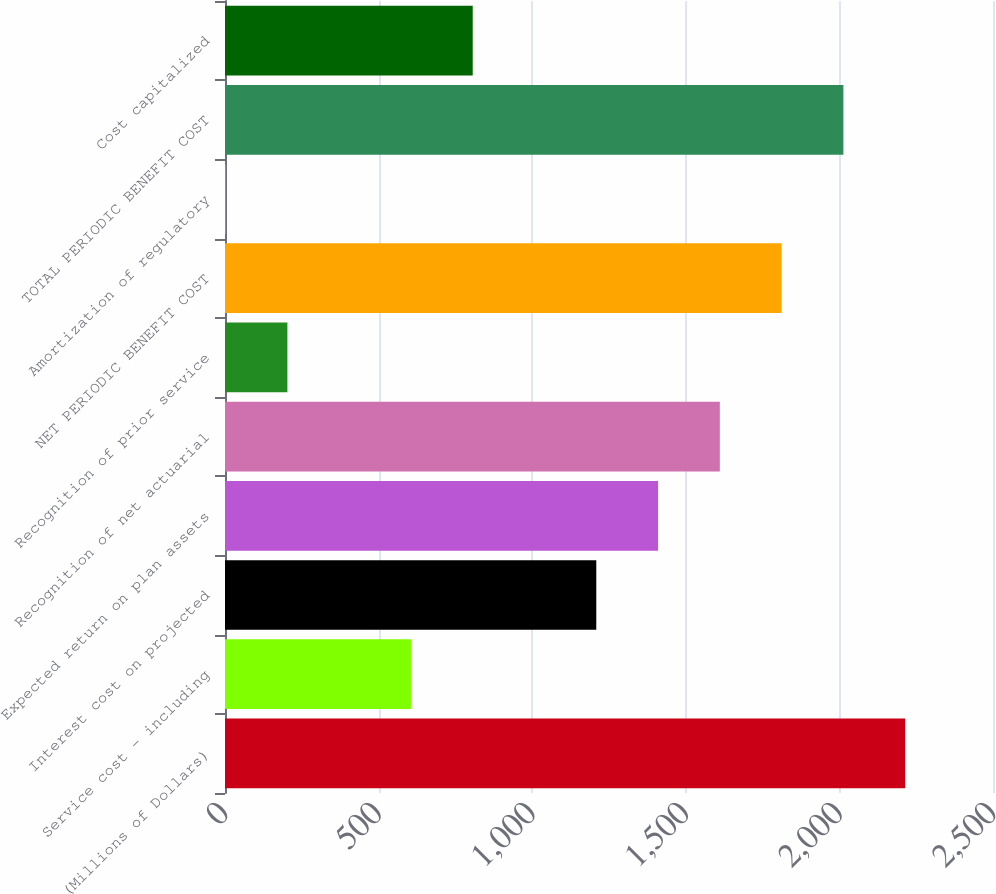Convert chart to OTSL. <chart><loc_0><loc_0><loc_500><loc_500><bar_chart><fcel>(Millions of Dollars)<fcel>Service cost - including<fcel>Interest cost on projected<fcel>Expected return on plan assets<fcel>Recognition of net actuarial<fcel>Recognition of prior service<fcel>NET PERIODIC BENEFIT COST<fcel>Amortization of regulatory<fcel>TOTAL PERIODIC BENEFIT COST<fcel>Cost capitalized<nl><fcel>2214.1<fcel>605.3<fcel>1208.6<fcel>1409.7<fcel>1610.8<fcel>203.1<fcel>1811.9<fcel>2<fcel>2013<fcel>806.4<nl></chart> 